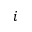Convert formula to latex. <formula><loc_0><loc_0><loc_500><loc_500>i</formula> 